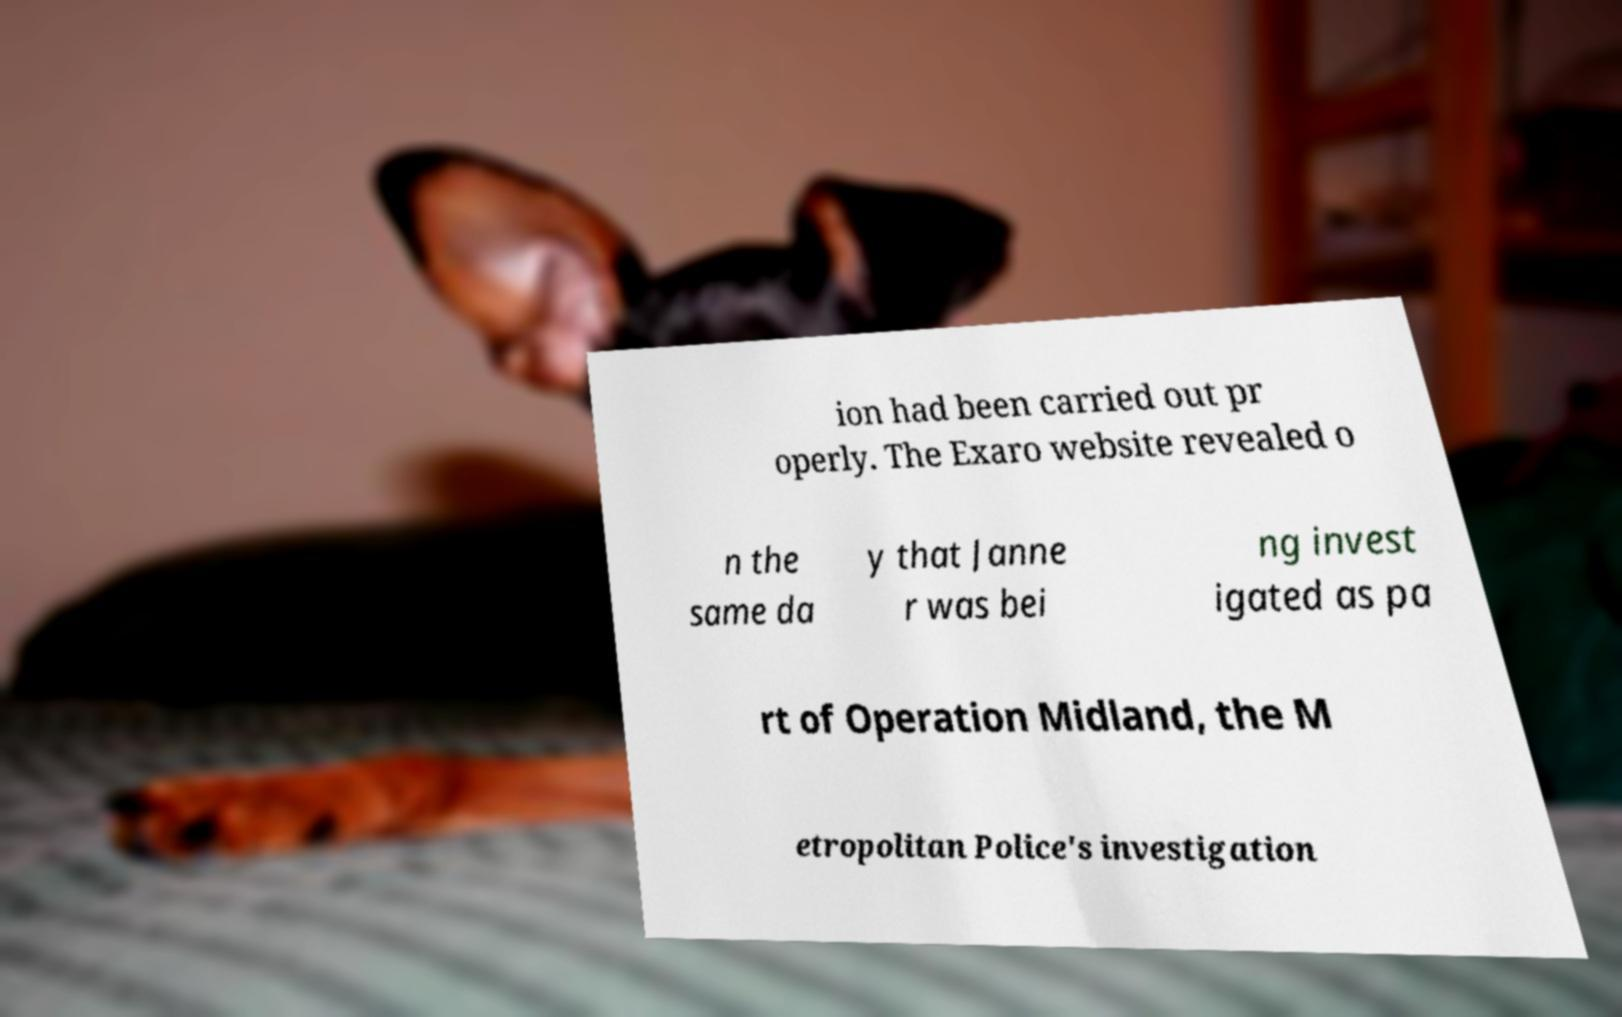Please read and relay the text visible in this image. What does it say? ion had been carried out pr operly. The Exaro website revealed o n the same da y that Janne r was bei ng invest igated as pa rt of Operation Midland, the M etropolitan Police's investigation 